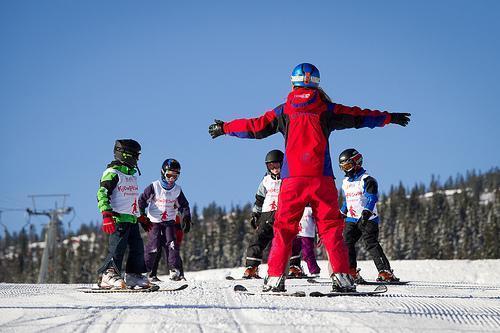How many people are there?
Give a very brief answer. 6. How many children are seen?
Give a very brief answer. 4. 